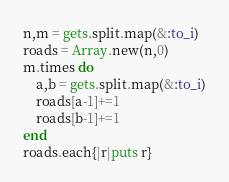Convert code to text. <code><loc_0><loc_0><loc_500><loc_500><_Ruby_>n,m = gets.split.map(&:to_i)
roads = Array.new(n,0)
m.times do
    a,b = gets.split.map(&:to_i)
    roads[a-1]+=1
    roads[b-1]+=1
end
roads.each{|r|puts r}</code> 